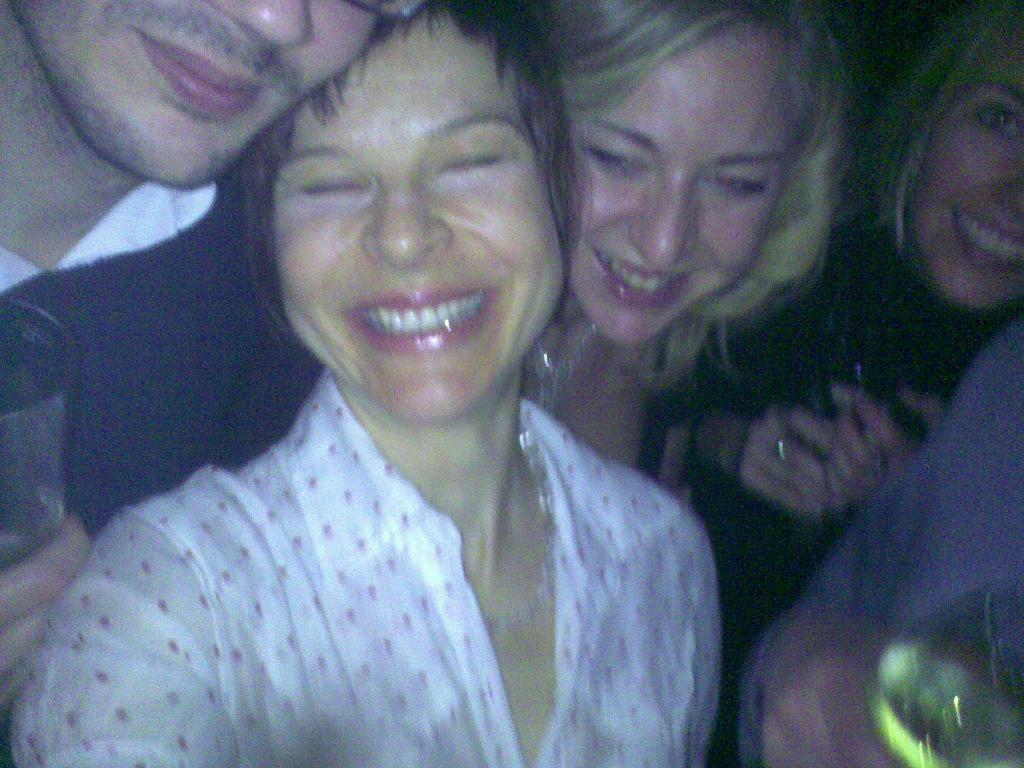What is present in the image? There are people in the image. Can you describe the expressions on the people's faces? The people have smiling faces. Can you tell me how many ants are crawling on the people's faces in the image? There are no ants present on the people's faces in the image. What type of bird is perched on the people's shoulders in the image? There are no birds, such as robins, present on the people's shoulders in the image. 